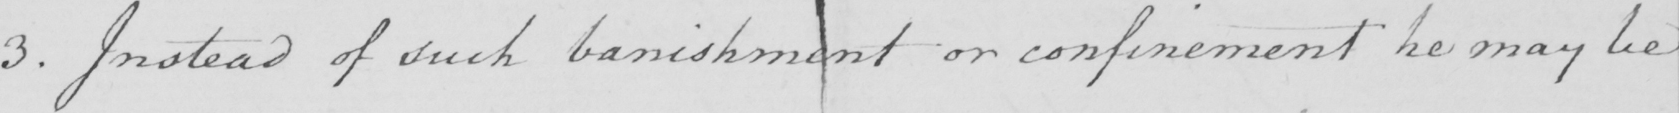Can you tell me what this handwritten text says? 3 . Instead of such banishment or confinement he may be 